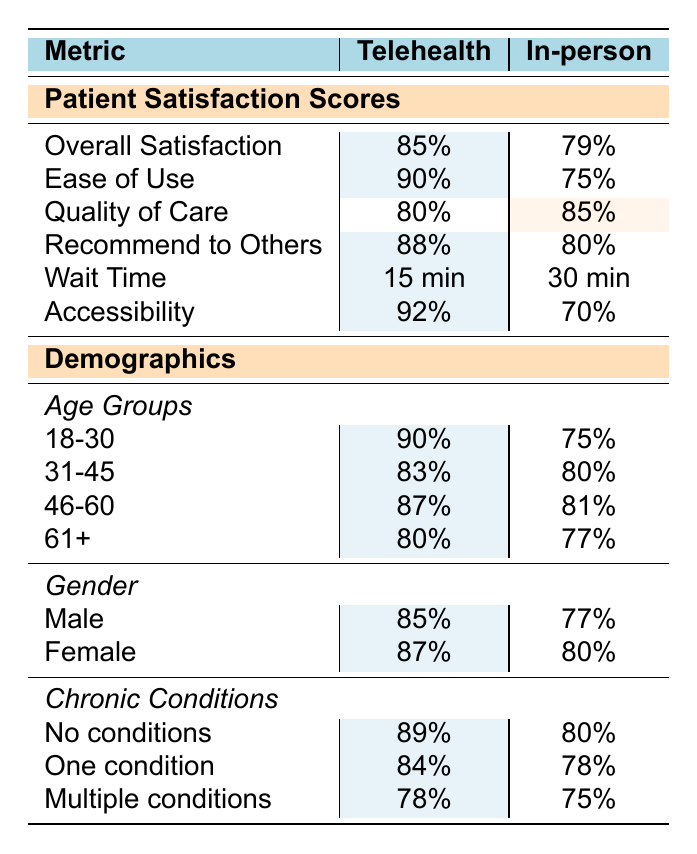What is the overall satisfaction score for Telehealth? The table shows a score of 85% for overall satisfaction under the Telehealth section.
Answer: 85% What is the wait time for in-person consultations? The table states that the wait time for in-person consultations is 30 minutes.
Answer: 30 minutes Which method has higher scores in 'ease of use'? Telehealth has an ease of use score of 90%, while in-person has a score of 75%. Telehealth is higher.
Answer: Telehealth What is the difference in patient satisfaction scores for 'recommend to others' between Telehealth and in-person consultations? Telehealth's score is 88% and in-person's score is 80%, so the difference is 88% - 80% = 8%.
Answer: 8% In which age group does Telehealth score the highest? According to the demographics, the age group 18-30 has the highest score for Telehealth at 90%.
Answer: 18-30 Are female patients more satisfied with Telehealth compared to male patients? Telehealth scores 87% for female patients and 85% for male patients, indicating female patients are slightly more satisfied.
Answer: Yes What is the average accessibility score for both methods? Telehealth scores 92% and in-person scores 70%. The average is (92% + 70%) / 2 = 81%.
Answer: 81% How does the quality of care score for Telehealth compare to in-person consultations? Telehealth has a quality of care score of 80%, while in-person has a score of 85%. In-person has a higher score.
Answer: In-person is higher Which category shows the lowest satisfaction for Telehealth based on chronic conditions? In the chronic conditions category, 'multiple conditions' has the lowest score for Telehealth at 78%.
Answer: Multiple conditions Is the overall satisfaction score for Telehealth higher than that for in-person consultations? Telehealth's overall satisfaction score is 85%, while in-person's is 79%. Thus, Telehealth is higher.
Answer: Yes 